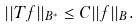<formula> <loc_0><loc_0><loc_500><loc_500>| | T f | | _ { B ^ { \ast } } \leq C | | f | | _ { B } .</formula> 